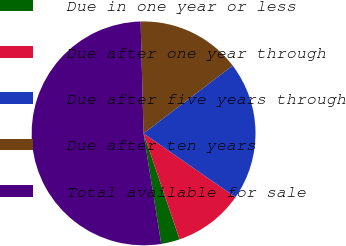Convert chart. <chart><loc_0><loc_0><loc_500><loc_500><pie_chart><fcel>Due in one year or less<fcel>Due after one year through<fcel>Due after five years through<fcel>Due after ten years<fcel>Total available for sale<nl><fcel>2.7%<fcel>10.13%<fcel>20.01%<fcel>15.07%<fcel>52.1%<nl></chart> 